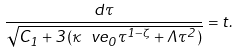Convert formula to latex. <formula><loc_0><loc_0><loc_500><loc_500>\frac { d \tau } { \sqrt { C _ { 1 } + 3 ( \kappa \ v e _ { 0 } \tau ^ { 1 - \zeta } + \Lambda \tau ^ { 2 } ) } } = t .</formula> 